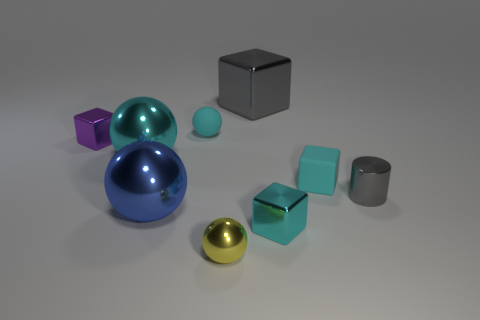There is a cyan metal object left of the gray metal cube; does it have the same size as the cyan rubber object left of the tiny yellow ball?
Your answer should be very brief. No. What number of objects are either cyan rubber spheres or gray rubber cylinders?
Make the answer very short. 1. Are there any large purple things that have the same shape as the small purple thing?
Offer a terse response. No. Are there fewer cyan metal blocks than cubes?
Keep it short and to the point. Yes. Is the yellow shiny object the same shape as the tiny purple shiny thing?
Your answer should be compact. No. What number of objects are either yellow metallic spheres or shiny objects that are left of the tiny yellow shiny thing?
Make the answer very short. 4. How many tiny purple metallic things are there?
Offer a very short reply. 1. Is there a blue metallic ball of the same size as the purple metallic thing?
Offer a terse response. No. Are there fewer purple things in front of the cyan metallic sphere than big blue things?
Give a very brief answer. Yes. Do the purple metallic thing and the cyan shiny cube have the same size?
Your response must be concise. Yes. 